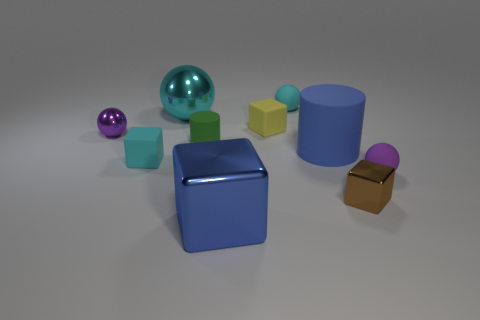Subtract 1 balls. How many balls are left? 3 Subtract all blocks. How many objects are left? 6 Add 6 large cylinders. How many large cylinders are left? 7 Add 7 tiny cyan metal blocks. How many tiny cyan metal blocks exist? 7 Subtract 0 yellow balls. How many objects are left? 10 Subtract all big brown matte cubes. Subtract all small metallic spheres. How many objects are left? 9 